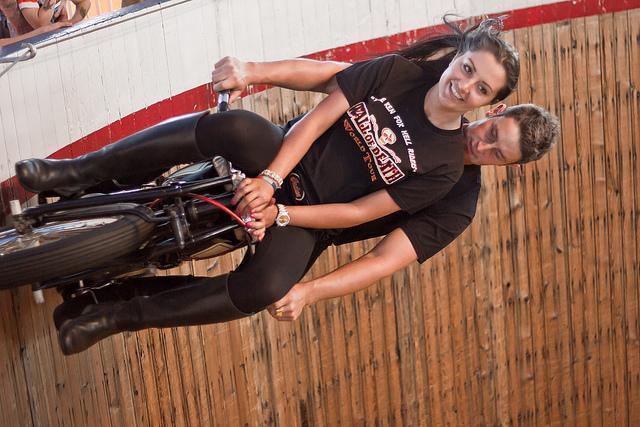How many people are there?
Give a very brief answer. 2. How many pieces of bread have an orange topping? there are pieces of bread without orange topping too?
Give a very brief answer. 0. 